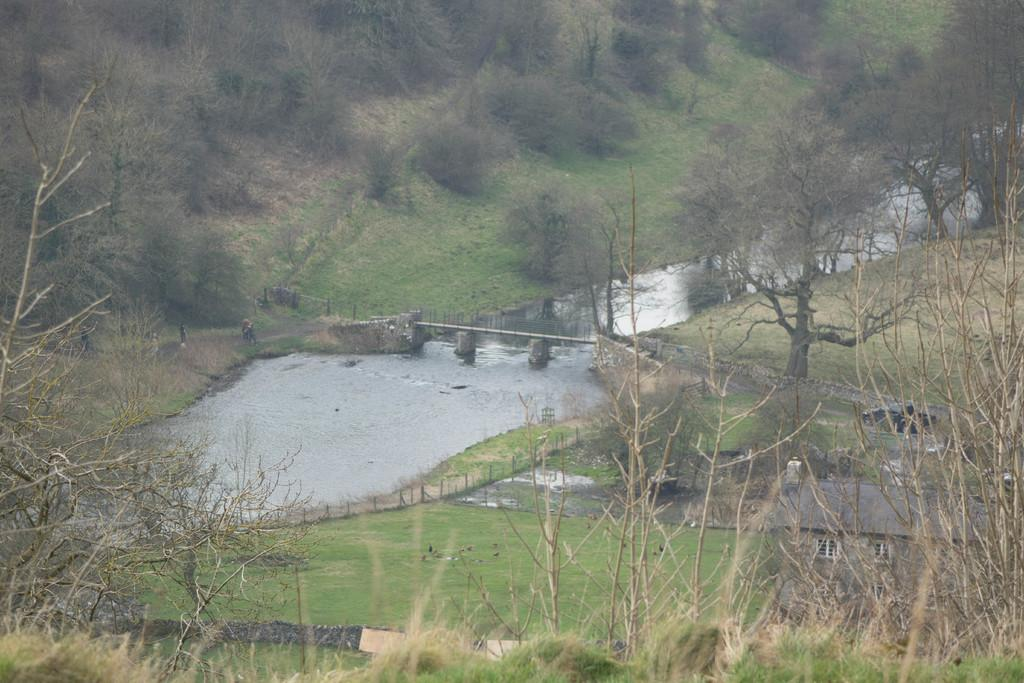What structure can be seen in the image? There is a bridge in the image. What type of vegetation is present in the image? There are trees, grass, and plants in the image. What natural element is visible in the image? There is water visible in the image. What type of buildings can be seen in the image? There are houses in the image. What else is present in the image besides the bridge and houses? There are poles in the image. What type of pie is being served on the bridge in the image? There is no pie present in the image; it features a bridge, trees, water, grass, plants, and houses. What season is depicted in the image? The image does not depict a specific season, as there are no seasonal indicators present. 